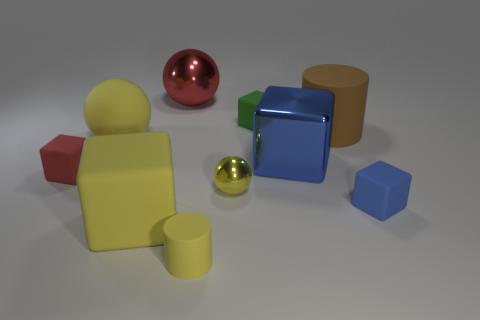The tiny matte block that is on the left side of the yellow cylinder is what color? red 